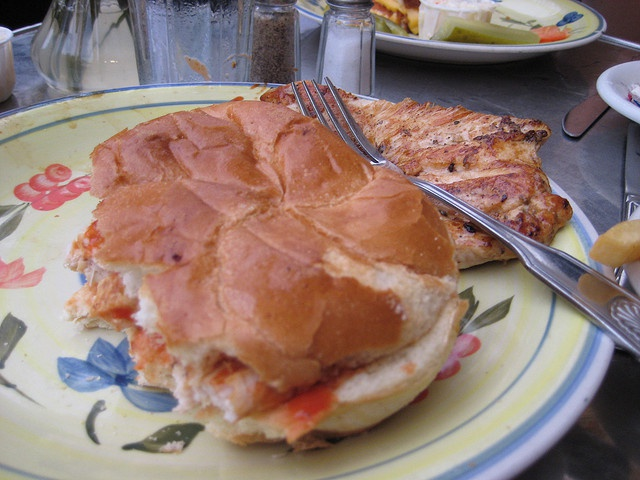Describe the objects in this image and their specific colors. I can see sandwich in black, salmon, brown, tan, and darkgray tones, dining table in black and gray tones, fork in black, gray, and brown tones, cup in black and gray tones, and cup in black and gray tones in this image. 